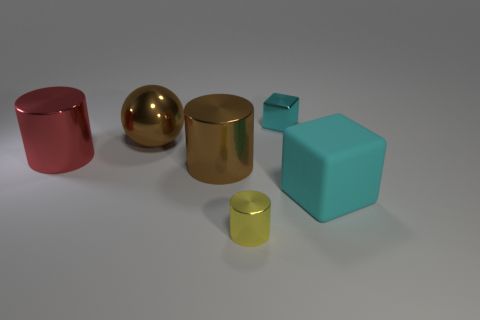Subtract all large shiny cylinders. How many cylinders are left? 1 Add 3 big yellow cubes. How many objects exist? 9 Subtract 1 cylinders. How many cylinders are left? 2 Subtract all spheres. How many objects are left? 5 Add 1 big cyan metal blocks. How many big cyan metal blocks exist? 1 Subtract 1 brown cylinders. How many objects are left? 5 Subtract all balls. Subtract all shiny cylinders. How many objects are left? 2 Add 1 big brown metal balls. How many big brown metal balls are left? 2 